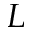Convert formula to latex. <formula><loc_0><loc_0><loc_500><loc_500>L</formula> 